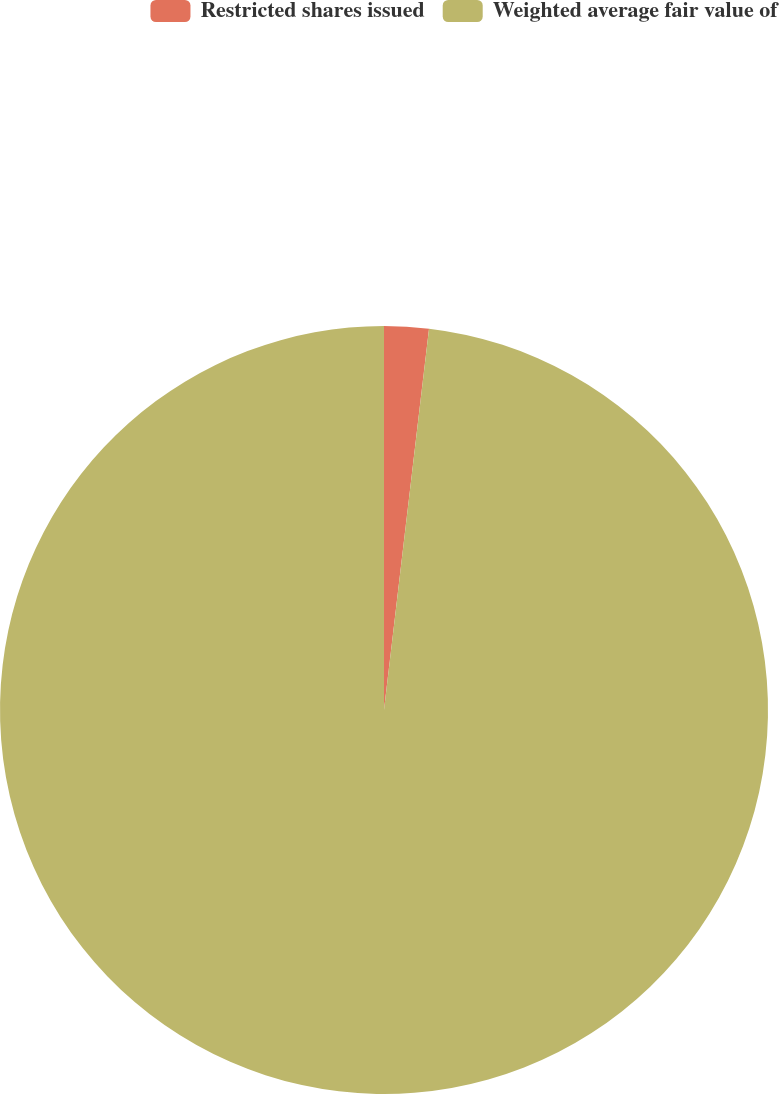Convert chart. <chart><loc_0><loc_0><loc_500><loc_500><pie_chart><fcel>Restricted shares issued<fcel>Weighted average fair value of<nl><fcel>1.87%<fcel>98.13%<nl></chart> 